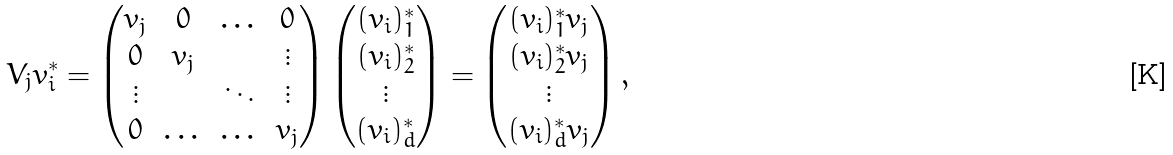<formula> <loc_0><loc_0><loc_500><loc_500>V _ { j } v _ { i } ^ { * } = \begin{pmatrix} v _ { j } & 0 & \dots & 0 \\ 0 & v _ { j } & & \vdots \\ \vdots & & \ddots & \vdots \\ 0 & \dots & \dots & v _ { j } \end{pmatrix} \begin{pmatrix} ( v _ { i } ) _ { 1 } ^ { * } \\ ( v _ { i } ) _ { 2 } ^ { * } \\ \vdots \\ ( v _ { i } ) _ { d } ^ { * } \end{pmatrix} = \begin{pmatrix} ( v _ { i } ) _ { 1 } ^ { * } v _ { j } \\ ( v _ { i } ) _ { 2 } ^ { * } v _ { j } \\ \vdots \\ ( v _ { i } ) _ { d } ^ { * } v _ { j } \end{pmatrix} ,</formula> 